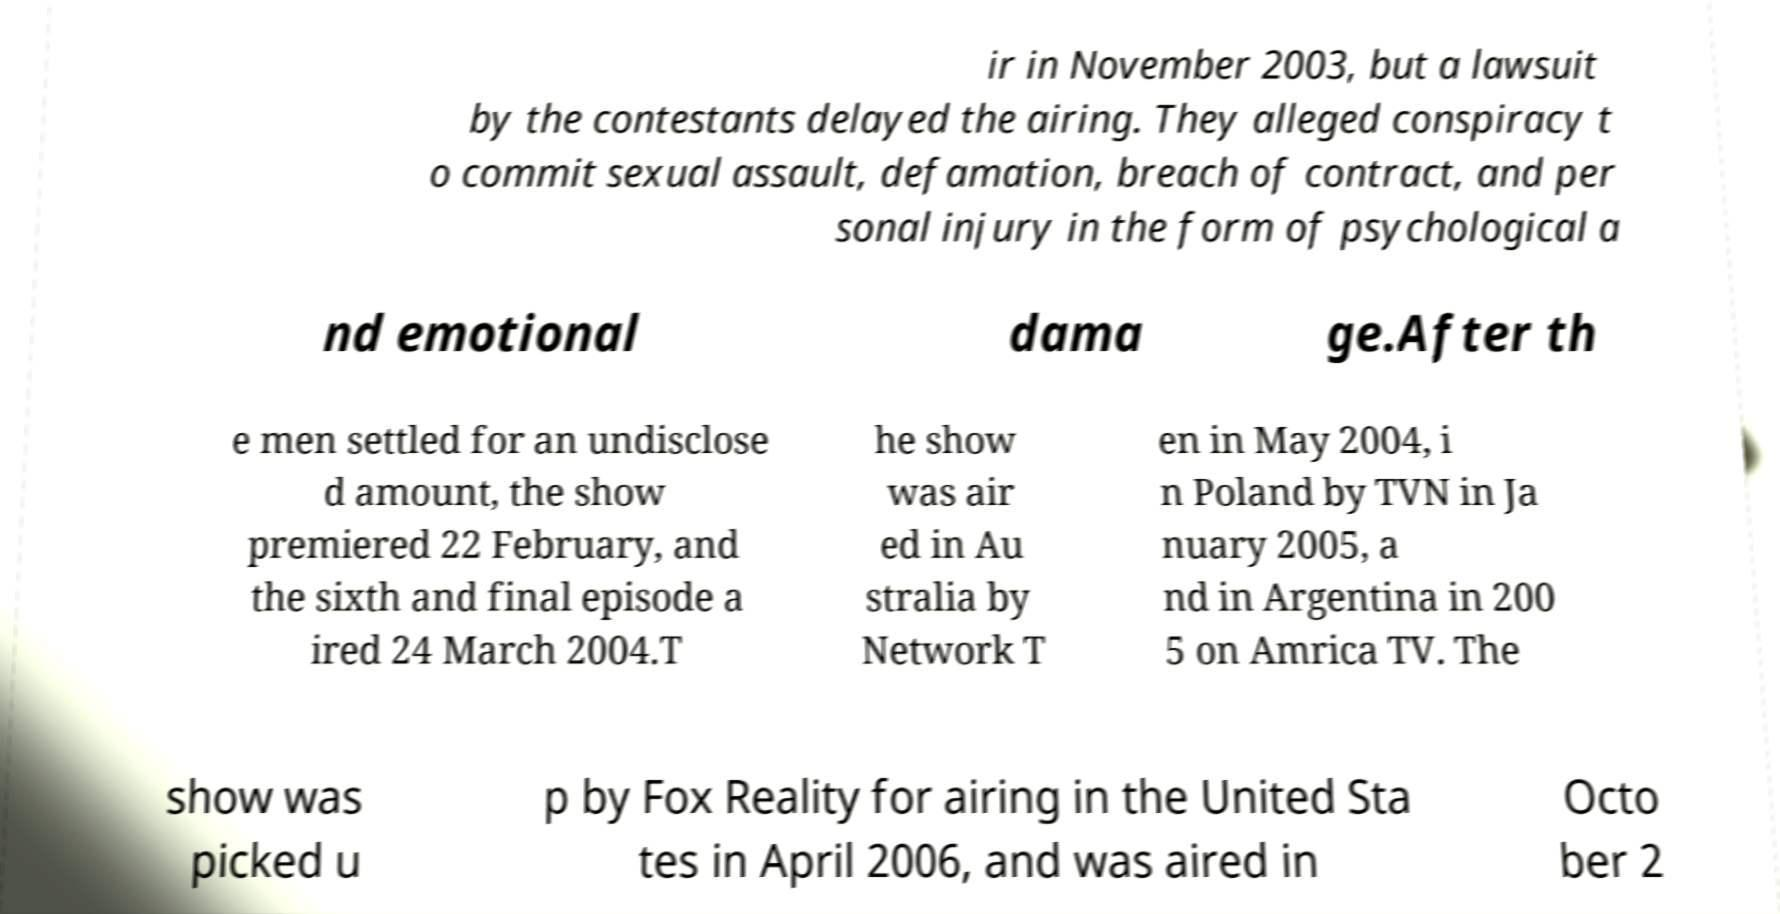Could you extract and type out the text from this image? ir in November 2003, but a lawsuit by the contestants delayed the airing. They alleged conspiracy t o commit sexual assault, defamation, breach of contract, and per sonal injury in the form of psychological a nd emotional dama ge.After th e men settled for an undisclose d amount, the show premiered 22 February, and the sixth and final episode a ired 24 March 2004.T he show was air ed in Au stralia by Network T en in May 2004, i n Poland by TVN in Ja nuary 2005, a nd in Argentina in 200 5 on Amrica TV. The show was picked u p by Fox Reality for airing in the United Sta tes in April 2006, and was aired in Octo ber 2 